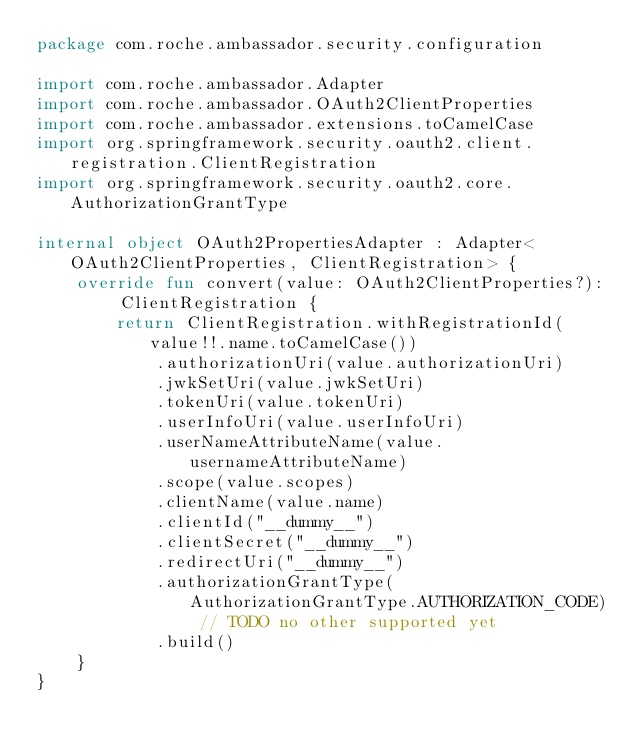<code> <loc_0><loc_0><loc_500><loc_500><_Kotlin_>package com.roche.ambassador.security.configuration

import com.roche.ambassador.Adapter
import com.roche.ambassador.OAuth2ClientProperties
import com.roche.ambassador.extensions.toCamelCase
import org.springframework.security.oauth2.client.registration.ClientRegistration
import org.springframework.security.oauth2.core.AuthorizationGrantType

internal object OAuth2PropertiesAdapter : Adapter<OAuth2ClientProperties, ClientRegistration> {
    override fun convert(value: OAuth2ClientProperties?): ClientRegistration {
        return ClientRegistration.withRegistrationId(value!!.name.toCamelCase())
            .authorizationUri(value.authorizationUri)
            .jwkSetUri(value.jwkSetUri)
            .tokenUri(value.tokenUri)
            .userInfoUri(value.userInfoUri)
            .userNameAttributeName(value.usernameAttributeName)
            .scope(value.scopes)
            .clientName(value.name)
            .clientId("__dummy__")
            .clientSecret("__dummy__")
            .redirectUri("__dummy__")
            .authorizationGrantType(AuthorizationGrantType.AUTHORIZATION_CODE) // TODO no other supported yet
            .build()
    }
}
</code> 